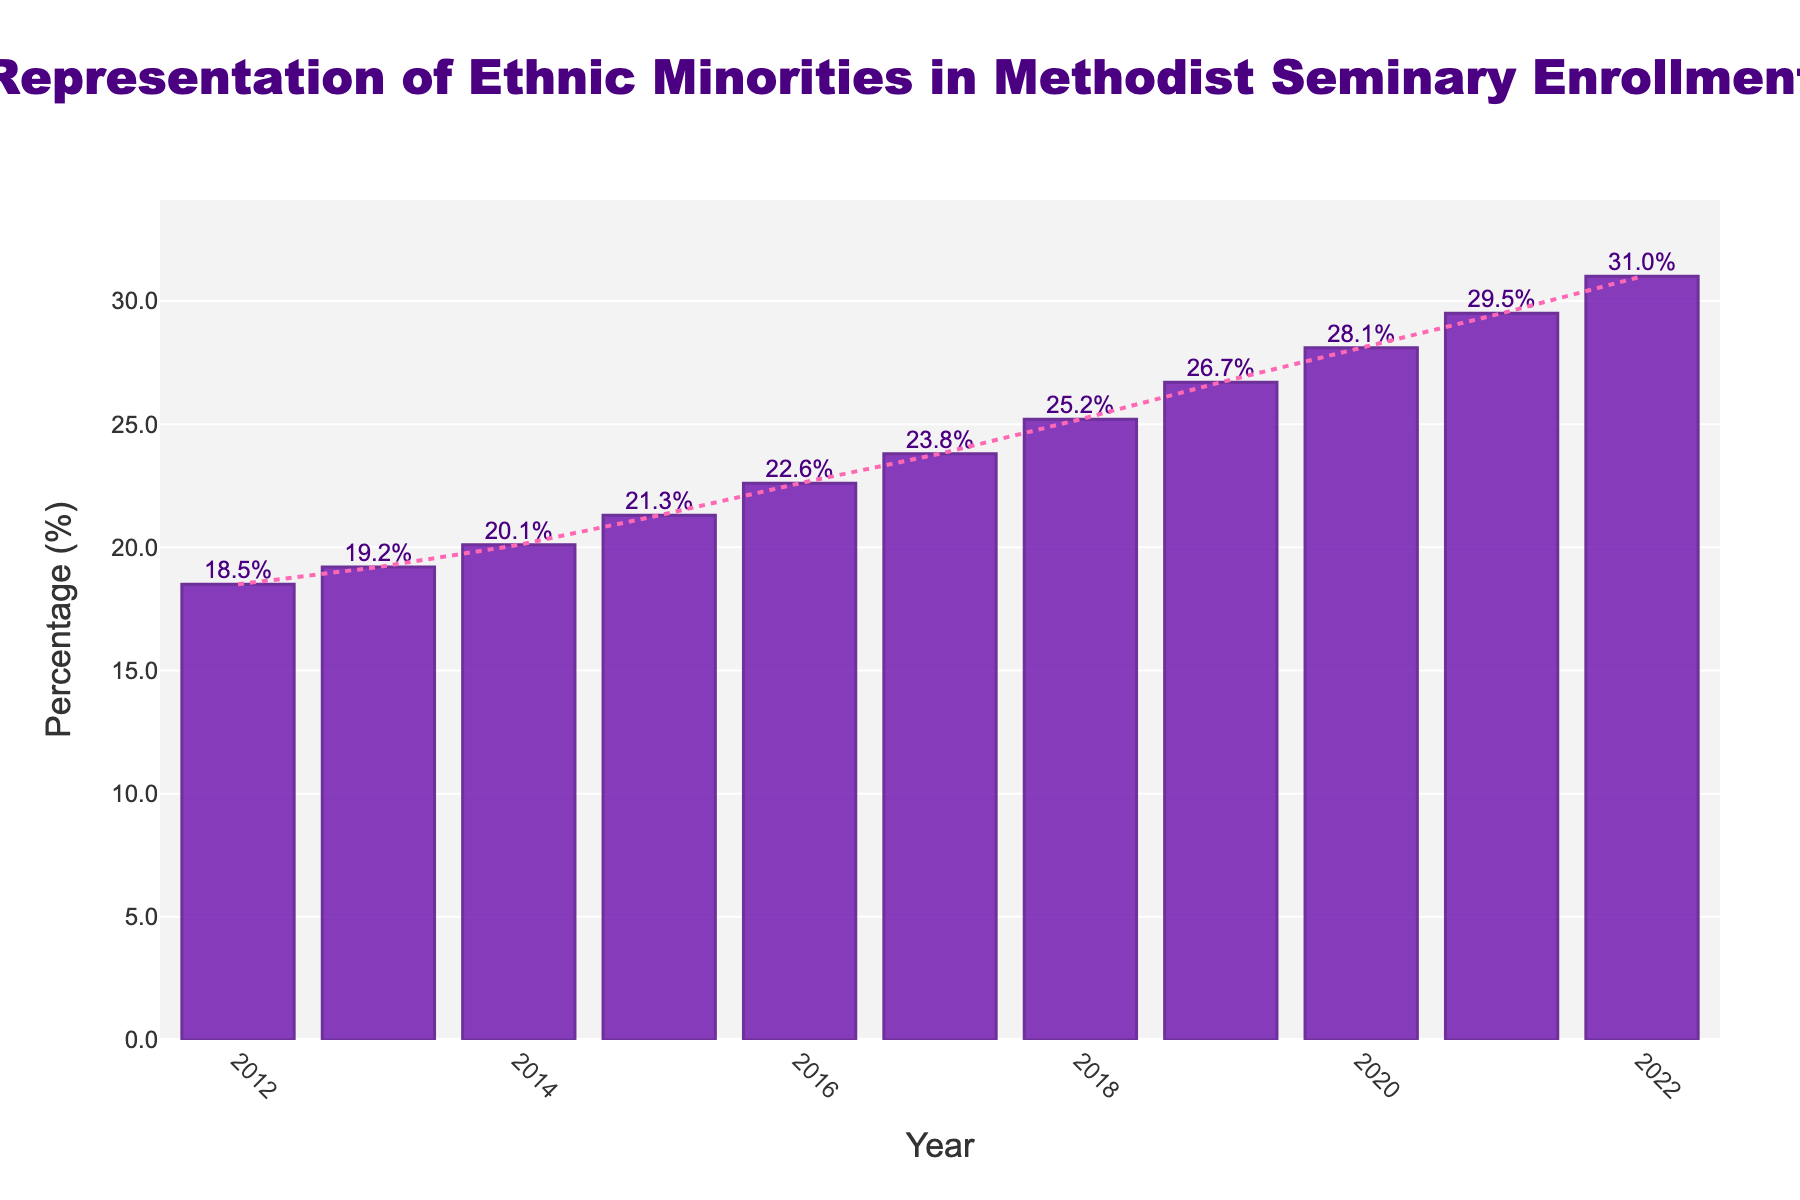What is the percentage of ethnic minorities in the year 2020? Look at the bar labeled for the year 2020 and note its height, which represents the percentage of ethnic minorities.
Answer: 28.1% In which year did the representation of ethnic minorities first exceed 25%? Identify the first bar that surpasses the 25% mark by looking from left to right.
Answer: 2018 By how many percentage points did the representation of ethnic minorities increase from 2012 to 2022? Subtract the percentage value for 2012 from the percentage value for 2022. Calculation: 31.0% (2022) - 18.5% (2012) = 12.5 percentage points.
Answer: 12.5% What is the average representation of ethnic minorities from 2015 to 2019? Sum the percentages from 2015 to 2019 and divide by the number of years. Calculation: (21.3 + 22.6 + 23.8 + 25.2 + 26.7) / 5 = 23.92%
Answer: 23.92% In which year was the growth in percentage of ethnic minorities the highest compared to the previous year? Calculate the difference year-to-year and find the maximum. (2013-2012=0.7, 2014-2013=0.9, 2015-2014=1.2, 2016-2015=1.3, 2017-2016=1.2, 2018-2017=1.4, 2019-2018=1.5, 2020-2019=1.4, 2021-2020=1.4, 2022-2021=1.5). The highest growth is between 2021 and 2022 or 2019 and 2020.
Answer: 2019 or 2022 Did the percentage increase every single year from 2012 to 2022? Check if each year's bar is taller than the previous year's bar.
Answer: Yes What is the difference in representation between the years with the highest and the lowest percentages? Identify the highest and lowest percentages (31.0% in 2022 and 18.5% in 2012), then subtract the lowest from the highest. Calculation: 31.0 - 18.5 = 12.5.
Answer: 12.5% Which year shows a percentage closest to the median value from 2012 to 2022? List all percentage values, find the median and compare each year's value to this median. Median: 23.8%. The closest year is 2017.
Answer: 2017 What is the overall trend in the representation of ethnic minorities from 2012 to 2022? Observe the bars' general direction over the years—from lower values on the left to higher values on the right.
Answer: Increasing 